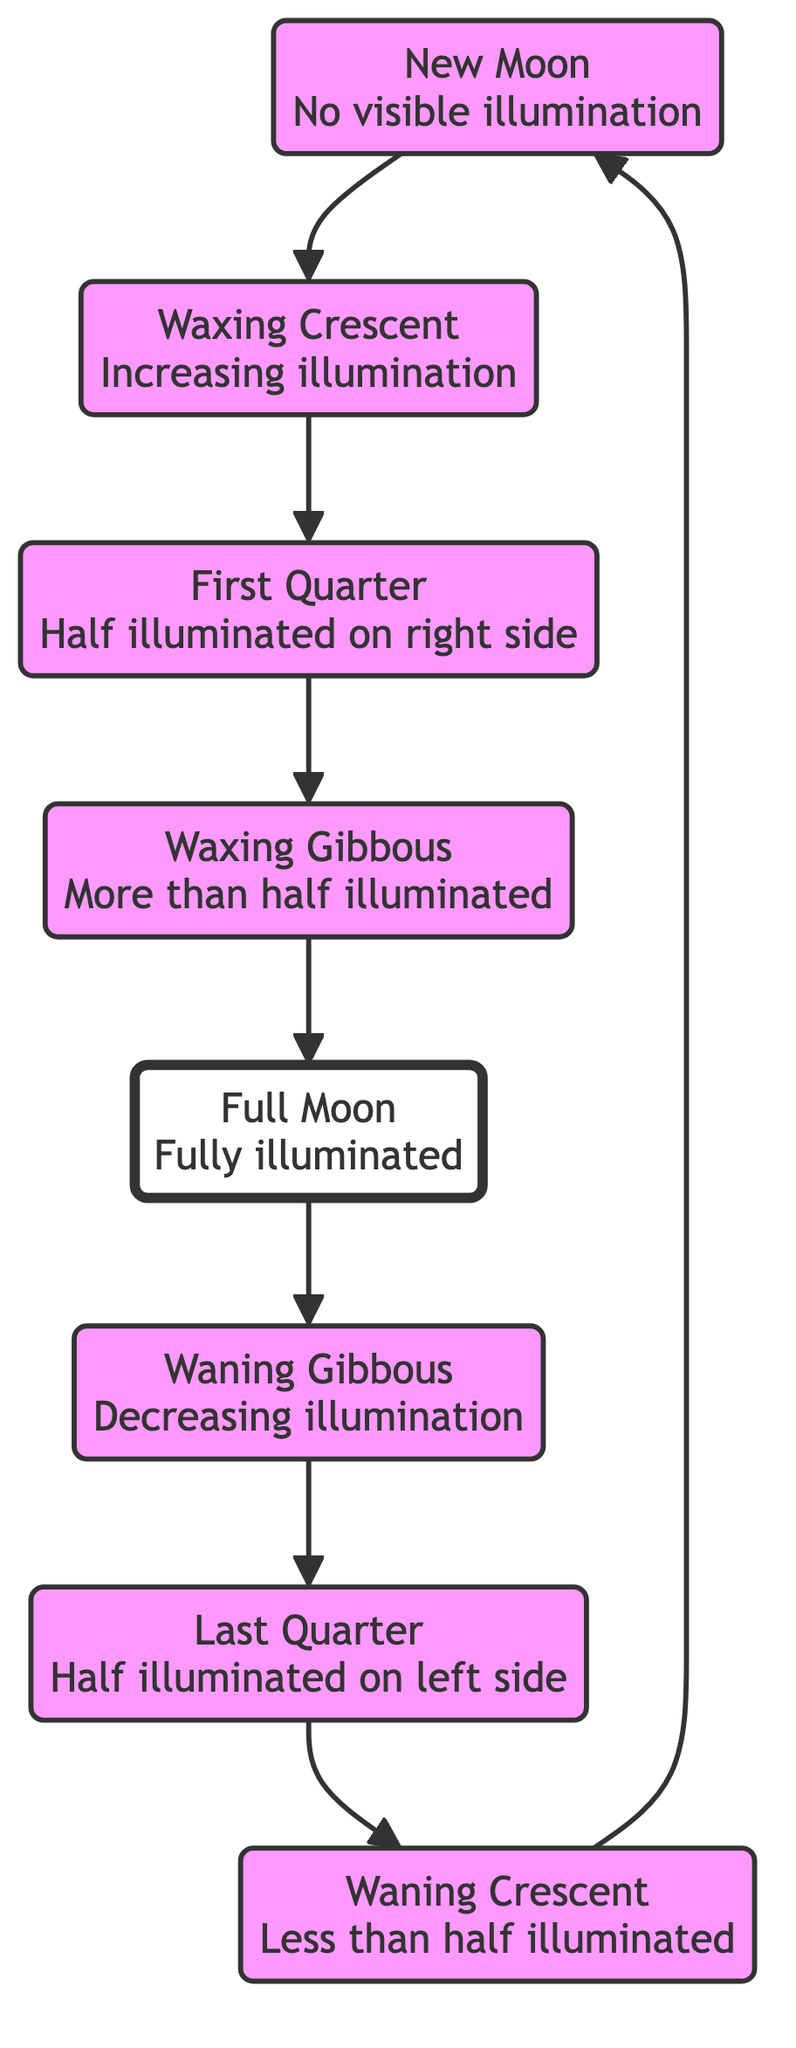What phase has no visible illumination? The diagram indicates that the "New Moon" phase is defined as having "No visible illumination." Thus, when asked about the phase without any visible light, it directly refers to the New Moon.
Answer: New Moon What comes after the Waxing Crescent phase? By following the flow of the diagram, the sequence of phases shows that after the "Waxing Crescent" phase, the next progression is to the "First Quarter." This follows the defined order of lunar phases presented.
Answer: First Quarter How many phases are represented in this diagram? The diagram includes a total of eight phases: New Moon, Waxing Crescent, First Quarter, Waxing Gibbous, Full Moon, Waning Gibbous, Last Quarter, and Waning Crescent. Counting all these phases confirms there are eight.
Answer: 8 What phase is fully illuminated? The "Full Moon" phase is characterized in the diagram as "Fully illuminated," which means it receives maximum sunlight and is completely visible in the night sky.
Answer: Full Moon Which phase has decreasing illumination? The "Waning Gibbous" phase is described as having "Decreasing illumination." This means that following the Full Moon, it starts to reflect less light as it moves towards the Last Quarter.
Answer: Waning Gibbous What is the phase following Last Quarter? Referring to the diagram's flow, after reaching the "Last Quarter," the next phase is the "Waning Crescent." This can be easily noted by continuing through the edges connected in the chart.
Answer: Waning Crescent Which two phases are half illuminated? According to the diagram, the phases that are identified as having "Half illuminated" status are the "First Quarter" and "Last Quarter." Each phase represents a symmetrical illumination based on the Moon's position relative to Earth and the Sun.
Answer: First Quarter and Last Quarter What phase does illumination start to increase? The "Waxing Crescent" phase represents the start of increasing illumination. The diagram strategically places this phase after the New Moon, indicating the Moon's transition towards a fuller appearance.
Answer: Waxing Crescent What is the sequence of illumination from New Moon to Full Moon? Starting from the "New Moon," which has no illumination, the sequence progresses through "Waxing Crescent," "First Quarter," and "Waxing Gibbous" before culminating in the "Full Moon," where illumination is at its peak. This shows a clear and gradual increase in visibility.
Answer: New Moon, Waxing Crescent, First Quarter, Waxing Gibbous, Full Moon 